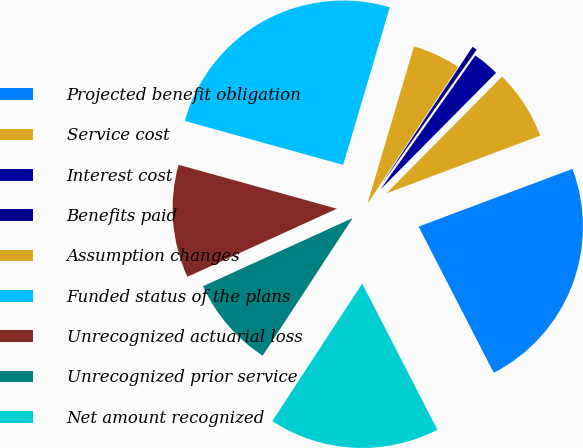<chart> <loc_0><loc_0><loc_500><loc_500><pie_chart><fcel>Projected benefit obligation<fcel>Service cost<fcel>Interest cost<fcel>Benefits paid<fcel>Assumption changes<fcel>Funded status of the plans<fcel>Unrecognized actuarial loss<fcel>Unrecognized prior service<fcel>Net amount recognized<nl><fcel>23.15%<fcel>6.86%<fcel>2.62%<fcel>0.49%<fcel>4.74%<fcel>25.27%<fcel>11.11%<fcel>8.98%<fcel>16.78%<nl></chart> 